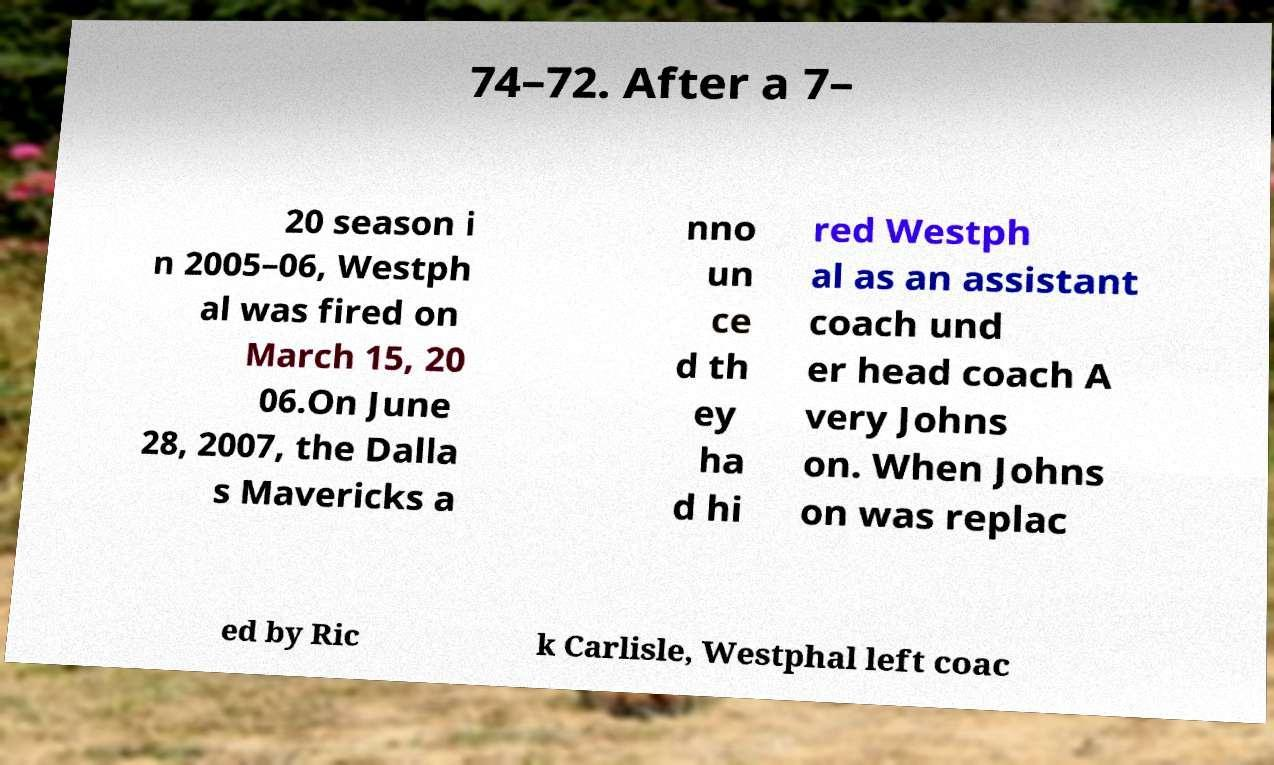What messages or text are displayed in this image? I need them in a readable, typed format. 74–72. After a 7– 20 season i n 2005–06, Westph al was fired on March 15, 20 06.On June 28, 2007, the Dalla s Mavericks a nno un ce d th ey ha d hi red Westph al as an assistant coach und er head coach A very Johns on. When Johns on was replac ed by Ric k Carlisle, Westphal left coac 